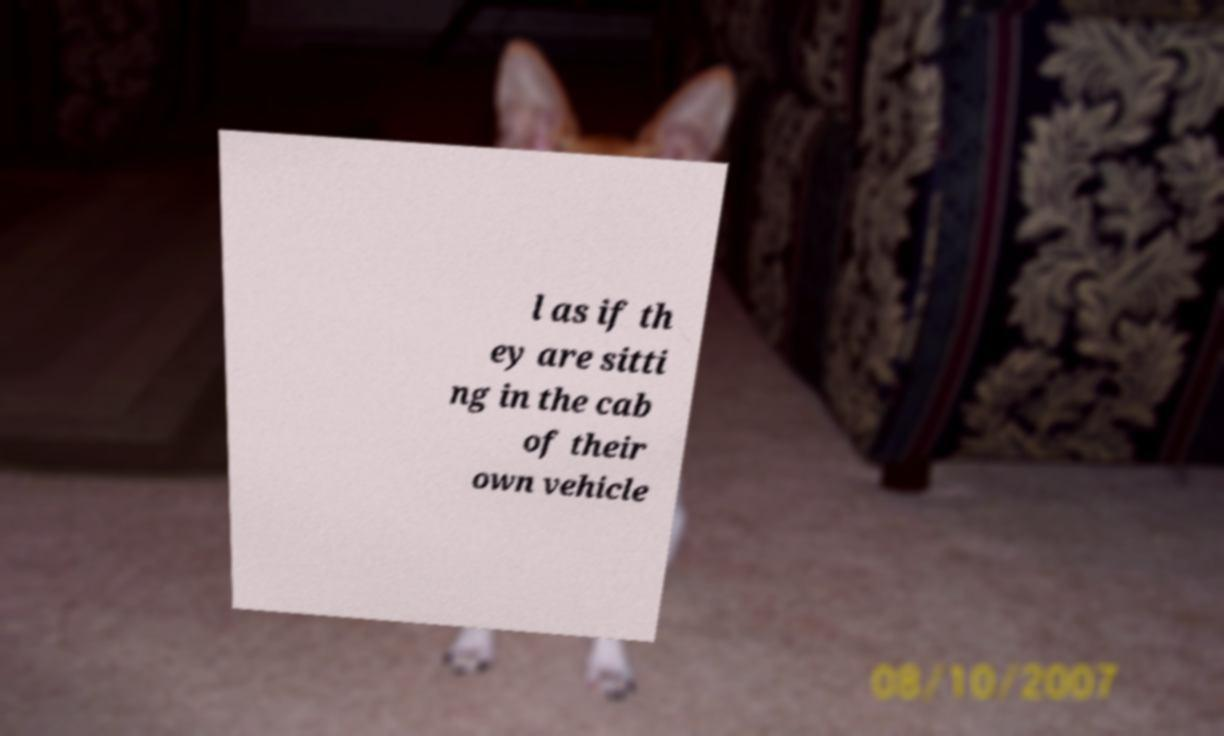Can you read and provide the text displayed in the image?This photo seems to have some interesting text. Can you extract and type it out for me? l as if th ey are sitti ng in the cab of their own vehicle 